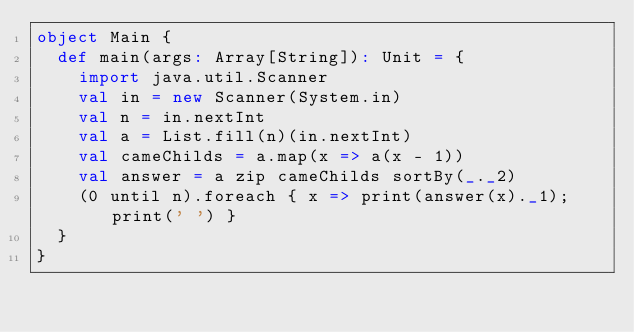Convert code to text. <code><loc_0><loc_0><loc_500><loc_500><_Scala_>object Main {
  def main(args: Array[String]): Unit = {
    import java.util.Scanner
    val in = new Scanner(System.in)
    val n = in.nextInt
    val a = List.fill(n)(in.nextInt)
    val cameChilds = a.map(x => a(x - 1))
    val answer = a zip cameChilds sortBy(_._2)
    (0 until n).foreach { x => print(answer(x)._1); print(' ') }
  }
}</code> 